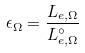<formula> <loc_0><loc_0><loc_500><loc_500>\epsilon _ { \Omega } = \frac { L _ { e , \Omega } } { L _ { e , \Omega } ^ { \circ } }</formula> 